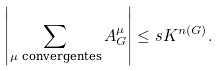<formula> <loc_0><loc_0><loc_500><loc_500>\left | \sum _ { \mu \text { convergentes} } A _ { G } ^ { \mu } \right | \leq s & K ^ { n ( G ) } .</formula> 